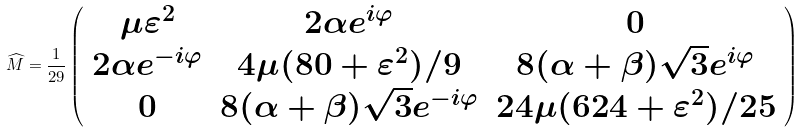<formula> <loc_0><loc_0><loc_500><loc_500>\widehat { M } = \frac { 1 } { 2 9 } \left ( \begin{array} { c c c } \mu \varepsilon ^ { 2 } & 2 \alpha e ^ { i \varphi } & 0 \\ 2 \alpha e ^ { - i \varphi } & 4 \mu ( 8 0 + \varepsilon ^ { 2 } ) / 9 & 8 ( \alpha + \beta ) \sqrt { 3 } e ^ { i \varphi } \\ 0 & 8 ( \alpha + \beta ) \sqrt { 3 } e ^ { - i \varphi } & 2 4 \mu ( 6 2 4 + \varepsilon ^ { 2 } ) / 2 5 \end{array} \right )</formula> 